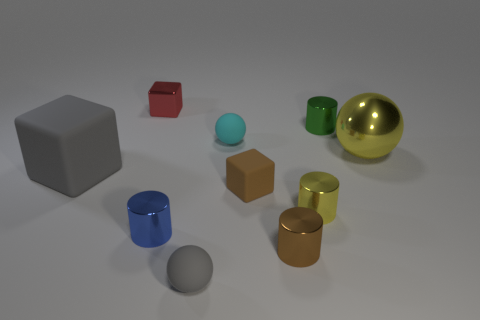How many tiny things are behind the yellow ball and to the left of the green shiny object?
Keep it short and to the point. 2. Does the green cylinder have the same material as the small block that is in front of the small green object?
Your answer should be compact. No. What number of green things are either cubes or big cubes?
Keep it short and to the point. 0. Are there any other shiny spheres of the same size as the gray sphere?
Ensure brevity in your answer.  No. There is a yellow object on the right side of the cylinder to the right of the yellow shiny thing in front of the big shiny sphere; what is its material?
Ensure brevity in your answer.  Metal. Are there an equal number of brown rubber things that are in front of the small blue metallic cylinder and small red metal cylinders?
Your answer should be very brief. Yes. Are the small block that is in front of the small red shiny cube and the big thing that is on the right side of the green metal object made of the same material?
Offer a terse response. No. What number of objects are either small blue metal balls or cylinders that are to the left of the green thing?
Ensure brevity in your answer.  3. Are there any yellow objects of the same shape as the red metallic object?
Your response must be concise. No. There is a gray object behind the matte ball in front of the tiny sphere that is right of the small gray sphere; what is its size?
Keep it short and to the point. Large. 